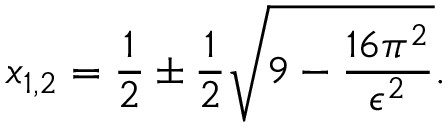Convert formula to latex. <formula><loc_0><loc_0><loc_500><loc_500>x _ { 1 , 2 } = \frac { 1 } { 2 } \pm \frac { 1 } { 2 } \sqrt { 9 - \frac { 1 6 \pi ^ { 2 } } { \epsilon ^ { 2 } } } .</formula> 